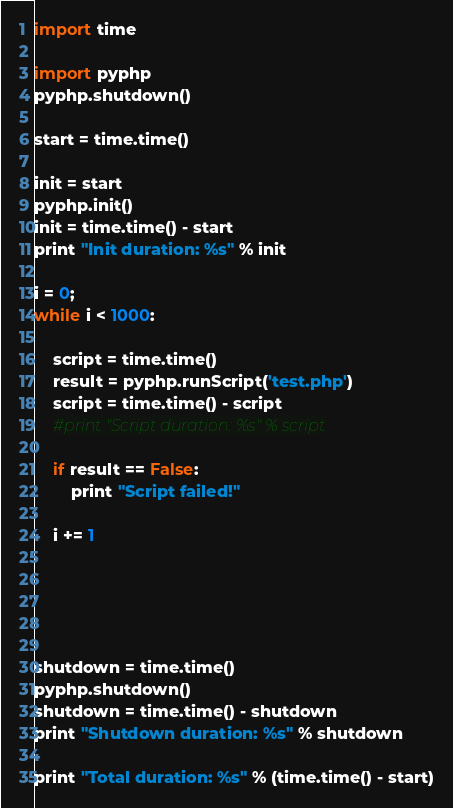Convert code to text. <code><loc_0><loc_0><loc_500><loc_500><_Python_>import time

import pyphp
pyphp.shutdown()

start = time.time()

init = start
pyphp.init()
init = time.time() - start
print "Init duration: %s" % init

i = 0;
while i < 1000:

	script = time.time()
	result = pyphp.runScript('test.php')
	script = time.time() - script
	#print "Script duration: %s" % script

	if result == False:
		print "Script failed!"
		
	i += 1





shutdown = time.time()
pyphp.shutdown()
shutdown = time.time() - shutdown
print "Shutdown duration: %s" % shutdown

print "Total duration: %s" % (time.time() - start)
</code> 